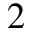Convert formula to latex. <formula><loc_0><loc_0><loc_500><loc_500>2</formula> 